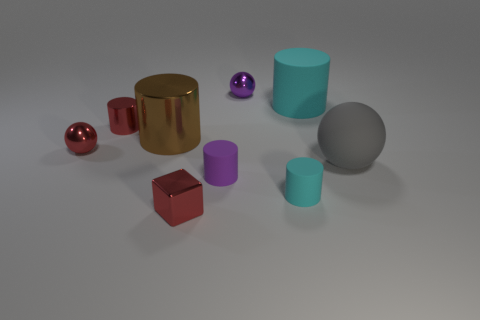Subtract 2 cylinders. How many cylinders are left? 3 Subtract all red cylinders. How many cylinders are left? 4 Subtract all red cylinders. How many cylinders are left? 4 Subtract all green cylinders. Subtract all purple cubes. How many cylinders are left? 5 Subtract all spheres. How many objects are left? 6 Subtract all big yellow metallic cylinders. Subtract all small metallic spheres. How many objects are left? 7 Add 2 big rubber spheres. How many big rubber spheres are left? 3 Add 3 tiny yellow cubes. How many tiny yellow cubes exist? 3 Subtract 0 blue balls. How many objects are left? 9 